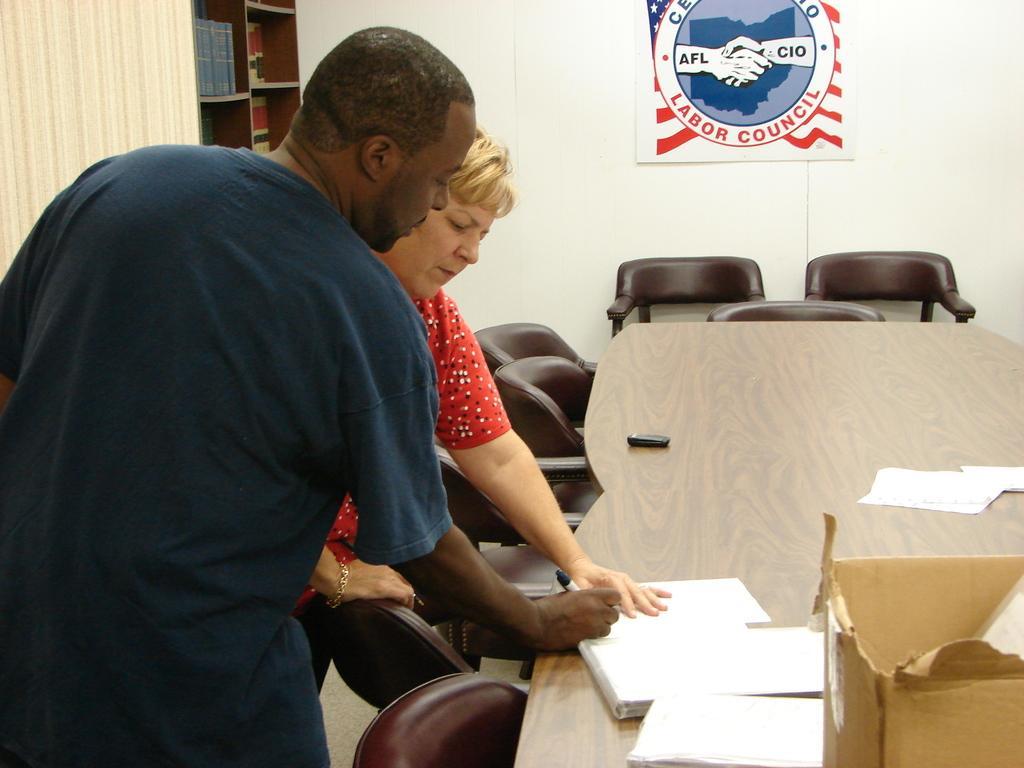How would you summarize this image in a sentence or two? In this image I can see a man and a woman are standing, I can also see number of chairs and a table. Here on this table I can see few papers and a box. 